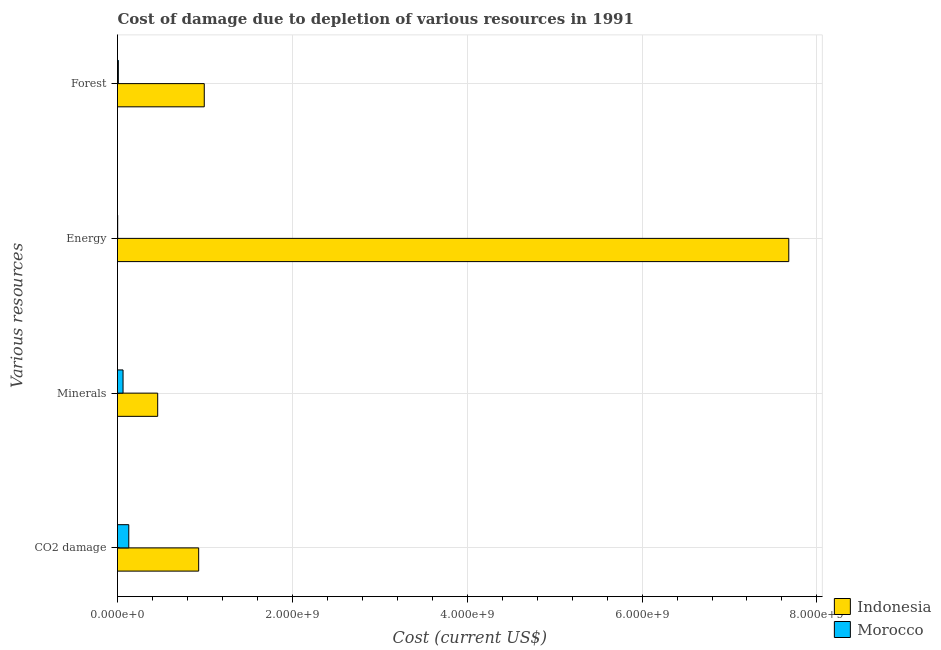How many groups of bars are there?
Your response must be concise. 4. Are the number of bars per tick equal to the number of legend labels?
Keep it short and to the point. Yes. Are the number of bars on each tick of the Y-axis equal?
Your answer should be very brief. Yes. How many bars are there on the 3rd tick from the bottom?
Ensure brevity in your answer.  2. What is the label of the 4th group of bars from the top?
Your answer should be very brief. CO2 damage. What is the cost of damage due to depletion of forests in Morocco?
Offer a terse response. 9.62e+06. Across all countries, what is the maximum cost of damage due to depletion of minerals?
Offer a very short reply. 4.60e+08. Across all countries, what is the minimum cost of damage due to depletion of forests?
Keep it short and to the point. 9.62e+06. In which country was the cost of damage due to depletion of minerals minimum?
Your answer should be compact. Morocco. What is the total cost of damage due to depletion of forests in the graph?
Ensure brevity in your answer.  1.00e+09. What is the difference between the cost of damage due to depletion of coal in Morocco and that in Indonesia?
Provide a short and direct response. -7.99e+08. What is the difference between the cost of damage due to depletion of minerals in Indonesia and the cost of damage due to depletion of forests in Morocco?
Your answer should be compact. 4.50e+08. What is the average cost of damage due to depletion of energy per country?
Your response must be concise. 3.84e+09. What is the difference between the cost of damage due to depletion of minerals and cost of damage due to depletion of forests in Morocco?
Provide a succinct answer. 5.37e+07. In how many countries, is the cost of damage due to depletion of energy greater than 1600000000 US$?
Provide a succinct answer. 1. What is the ratio of the cost of damage due to depletion of energy in Indonesia to that in Morocco?
Give a very brief answer. 3834.19. Is the difference between the cost of damage due to depletion of energy in Indonesia and Morocco greater than the difference between the cost of damage due to depletion of coal in Indonesia and Morocco?
Keep it short and to the point. Yes. What is the difference between the highest and the second highest cost of damage due to depletion of minerals?
Offer a terse response. 3.96e+08. What is the difference between the highest and the lowest cost of damage due to depletion of energy?
Offer a very short reply. 7.68e+09. In how many countries, is the cost of damage due to depletion of energy greater than the average cost of damage due to depletion of energy taken over all countries?
Provide a succinct answer. 1. Is the sum of the cost of damage due to depletion of energy in Indonesia and Morocco greater than the maximum cost of damage due to depletion of minerals across all countries?
Keep it short and to the point. Yes. What does the 1st bar from the top in CO2 damage represents?
Offer a terse response. Morocco. What does the 2nd bar from the bottom in CO2 damage represents?
Provide a short and direct response. Morocco. How many bars are there?
Keep it short and to the point. 8. Where does the legend appear in the graph?
Your answer should be compact. Bottom right. How many legend labels are there?
Offer a very short reply. 2. What is the title of the graph?
Provide a succinct answer. Cost of damage due to depletion of various resources in 1991 . Does "Mali" appear as one of the legend labels in the graph?
Your response must be concise. No. What is the label or title of the X-axis?
Make the answer very short. Cost (current US$). What is the label or title of the Y-axis?
Provide a short and direct response. Various resources. What is the Cost (current US$) in Indonesia in CO2 damage?
Your response must be concise. 9.28e+08. What is the Cost (current US$) of Morocco in CO2 damage?
Keep it short and to the point. 1.29e+08. What is the Cost (current US$) of Indonesia in Minerals?
Keep it short and to the point. 4.60e+08. What is the Cost (current US$) of Morocco in Minerals?
Provide a short and direct response. 6.33e+07. What is the Cost (current US$) of Indonesia in Energy?
Provide a short and direct response. 7.68e+09. What is the Cost (current US$) of Morocco in Energy?
Give a very brief answer. 2.00e+06. What is the Cost (current US$) in Indonesia in Forest?
Your response must be concise. 9.92e+08. What is the Cost (current US$) in Morocco in Forest?
Make the answer very short. 9.62e+06. Across all Various resources, what is the maximum Cost (current US$) of Indonesia?
Offer a terse response. 7.68e+09. Across all Various resources, what is the maximum Cost (current US$) in Morocco?
Keep it short and to the point. 1.29e+08. Across all Various resources, what is the minimum Cost (current US$) in Indonesia?
Offer a very short reply. 4.60e+08. Across all Various resources, what is the minimum Cost (current US$) in Morocco?
Offer a very short reply. 2.00e+06. What is the total Cost (current US$) in Indonesia in the graph?
Provide a short and direct response. 1.01e+1. What is the total Cost (current US$) in Morocco in the graph?
Make the answer very short. 2.04e+08. What is the difference between the Cost (current US$) in Indonesia in CO2 damage and that in Minerals?
Make the answer very short. 4.69e+08. What is the difference between the Cost (current US$) in Morocco in CO2 damage and that in Minerals?
Give a very brief answer. 6.57e+07. What is the difference between the Cost (current US$) of Indonesia in CO2 damage and that in Energy?
Ensure brevity in your answer.  -6.75e+09. What is the difference between the Cost (current US$) in Morocco in CO2 damage and that in Energy?
Make the answer very short. 1.27e+08. What is the difference between the Cost (current US$) in Indonesia in CO2 damage and that in Forest?
Offer a very short reply. -6.39e+07. What is the difference between the Cost (current US$) in Morocco in CO2 damage and that in Forest?
Offer a terse response. 1.19e+08. What is the difference between the Cost (current US$) of Indonesia in Minerals and that in Energy?
Provide a succinct answer. -7.22e+09. What is the difference between the Cost (current US$) in Morocco in Minerals and that in Energy?
Your answer should be very brief. 6.13e+07. What is the difference between the Cost (current US$) of Indonesia in Minerals and that in Forest?
Offer a very short reply. -5.33e+08. What is the difference between the Cost (current US$) of Morocco in Minerals and that in Forest?
Offer a terse response. 5.37e+07. What is the difference between the Cost (current US$) of Indonesia in Energy and that in Forest?
Offer a terse response. 6.69e+09. What is the difference between the Cost (current US$) in Morocco in Energy and that in Forest?
Your answer should be very brief. -7.62e+06. What is the difference between the Cost (current US$) of Indonesia in CO2 damage and the Cost (current US$) of Morocco in Minerals?
Your answer should be very brief. 8.65e+08. What is the difference between the Cost (current US$) of Indonesia in CO2 damage and the Cost (current US$) of Morocco in Energy?
Keep it short and to the point. 9.26e+08. What is the difference between the Cost (current US$) in Indonesia in CO2 damage and the Cost (current US$) in Morocco in Forest?
Offer a very short reply. 9.19e+08. What is the difference between the Cost (current US$) of Indonesia in Minerals and the Cost (current US$) of Morocco in Energy?
Keep it short and to the point. 4.58e+08. What is the difference between the Cost (current US$) in Indonesia in Minerals and the Cost (current US$) in Morocco in Forest?
Offer a terse response. 4.50e+08. What is the difference between the Cost (current US$) of Indonesia in Energy and the Cost (current US$) of Morocco in Forest?
Your answer should be compact. 7.67e+09. What is the average Cost (current US$) in Indonesia per Various resources?
Make the answer very short. 2.51e+09. What is the average Cost (current US$) of Morocco per Various resources?
Offer a terse response. 5.10e+07. What is the difference between the Cost (current US$) in Indonesia and Cost (current US$) in Morocco in CO2 damage?
Your response must be concise. 7.99e+08. What is the difference between the Cost (current US$) in Indonesia and Cost (current US$) in Morocco in Minerals?
Your answer should be very brief. 3.96e+08. What is the difference between the Cost (current US$) in Indonesia and Cost (current US$) in Morocco in Energy?
Ensure brevity in your answer.  7.68e+09. What is the difference between the Cost (current US$) of Indonesia and Cost (current US$) of Morocco in Forest?
Your response must be concise. 9.83e+08. What is the ratio of the Cost (current US$) of Indonesia in CO2 damage to that in Minerals?
Your answer should be very brief. 2.02. What is the ratio of the Cost (current US$) of Morocco in CO2 damage to that in Minerals?
Keep it short and to the point. 2.04. What is the ratio of the Cost (current US$) of Indonesia in CO2 damage to that in Energy?
Provide a short and direct response. 0.12. What is the ratio of the Cost (current US$) of Morocco in CO2 damage to that in Energy?
Keep it short and to the point. 64.43. What is the ratio of the Cost (current US$) in Indonesia in CO2 damage to that in Forest?
Provide a short and direct response. 0.94. What is the ratio of the Cost (current US$) of Morocco in CO2 damage to that in Forest?
Your answer should be compact. 13.41. What is the ratio of the Cost (current US$) of Indonesia in Minerals to that in Energy?
Your response must be concise. 0.06. What is the ratio of the Cost (current US$) in Morocco in Minerals to that in Energy?
Offer a very short reply. 31.63. What is the ratio of the Cost (current US$) of Indonesia in Minerals to that in Forest?
Provide a short and direct response. 0.46. What is the ratio of the Cost (current US$) in Morocco in Minerals to that in Forest?
Ensure brevity in your answer.  6.58. What is the ratio of the Cost (current US$) in Indonesia in Energy to that in Forest?
Keep it short and to the point. 7.74. What is the ratio of the Cost (current US$) of Morocco in Energy to that in Forest?
Your answer should be compact. 0.21. What is the difference between the highest and the second highest Cost (current US$) of Indonesia?
Provide a short and direct response. 6.69e+09. What is the difference between the highest and the second highest Cost (current US$) in Morocco?
Your response must be concise. 6.57e+07. What is the difference between the highest and the lowest Cost (current US$) of Indonesia?
Provide a short and direct response. 7.22e+09. What is the difference between the highest and the lowest Cost (current US$) in Morocco?
Keep it short and to the point. 1.27e+08. 